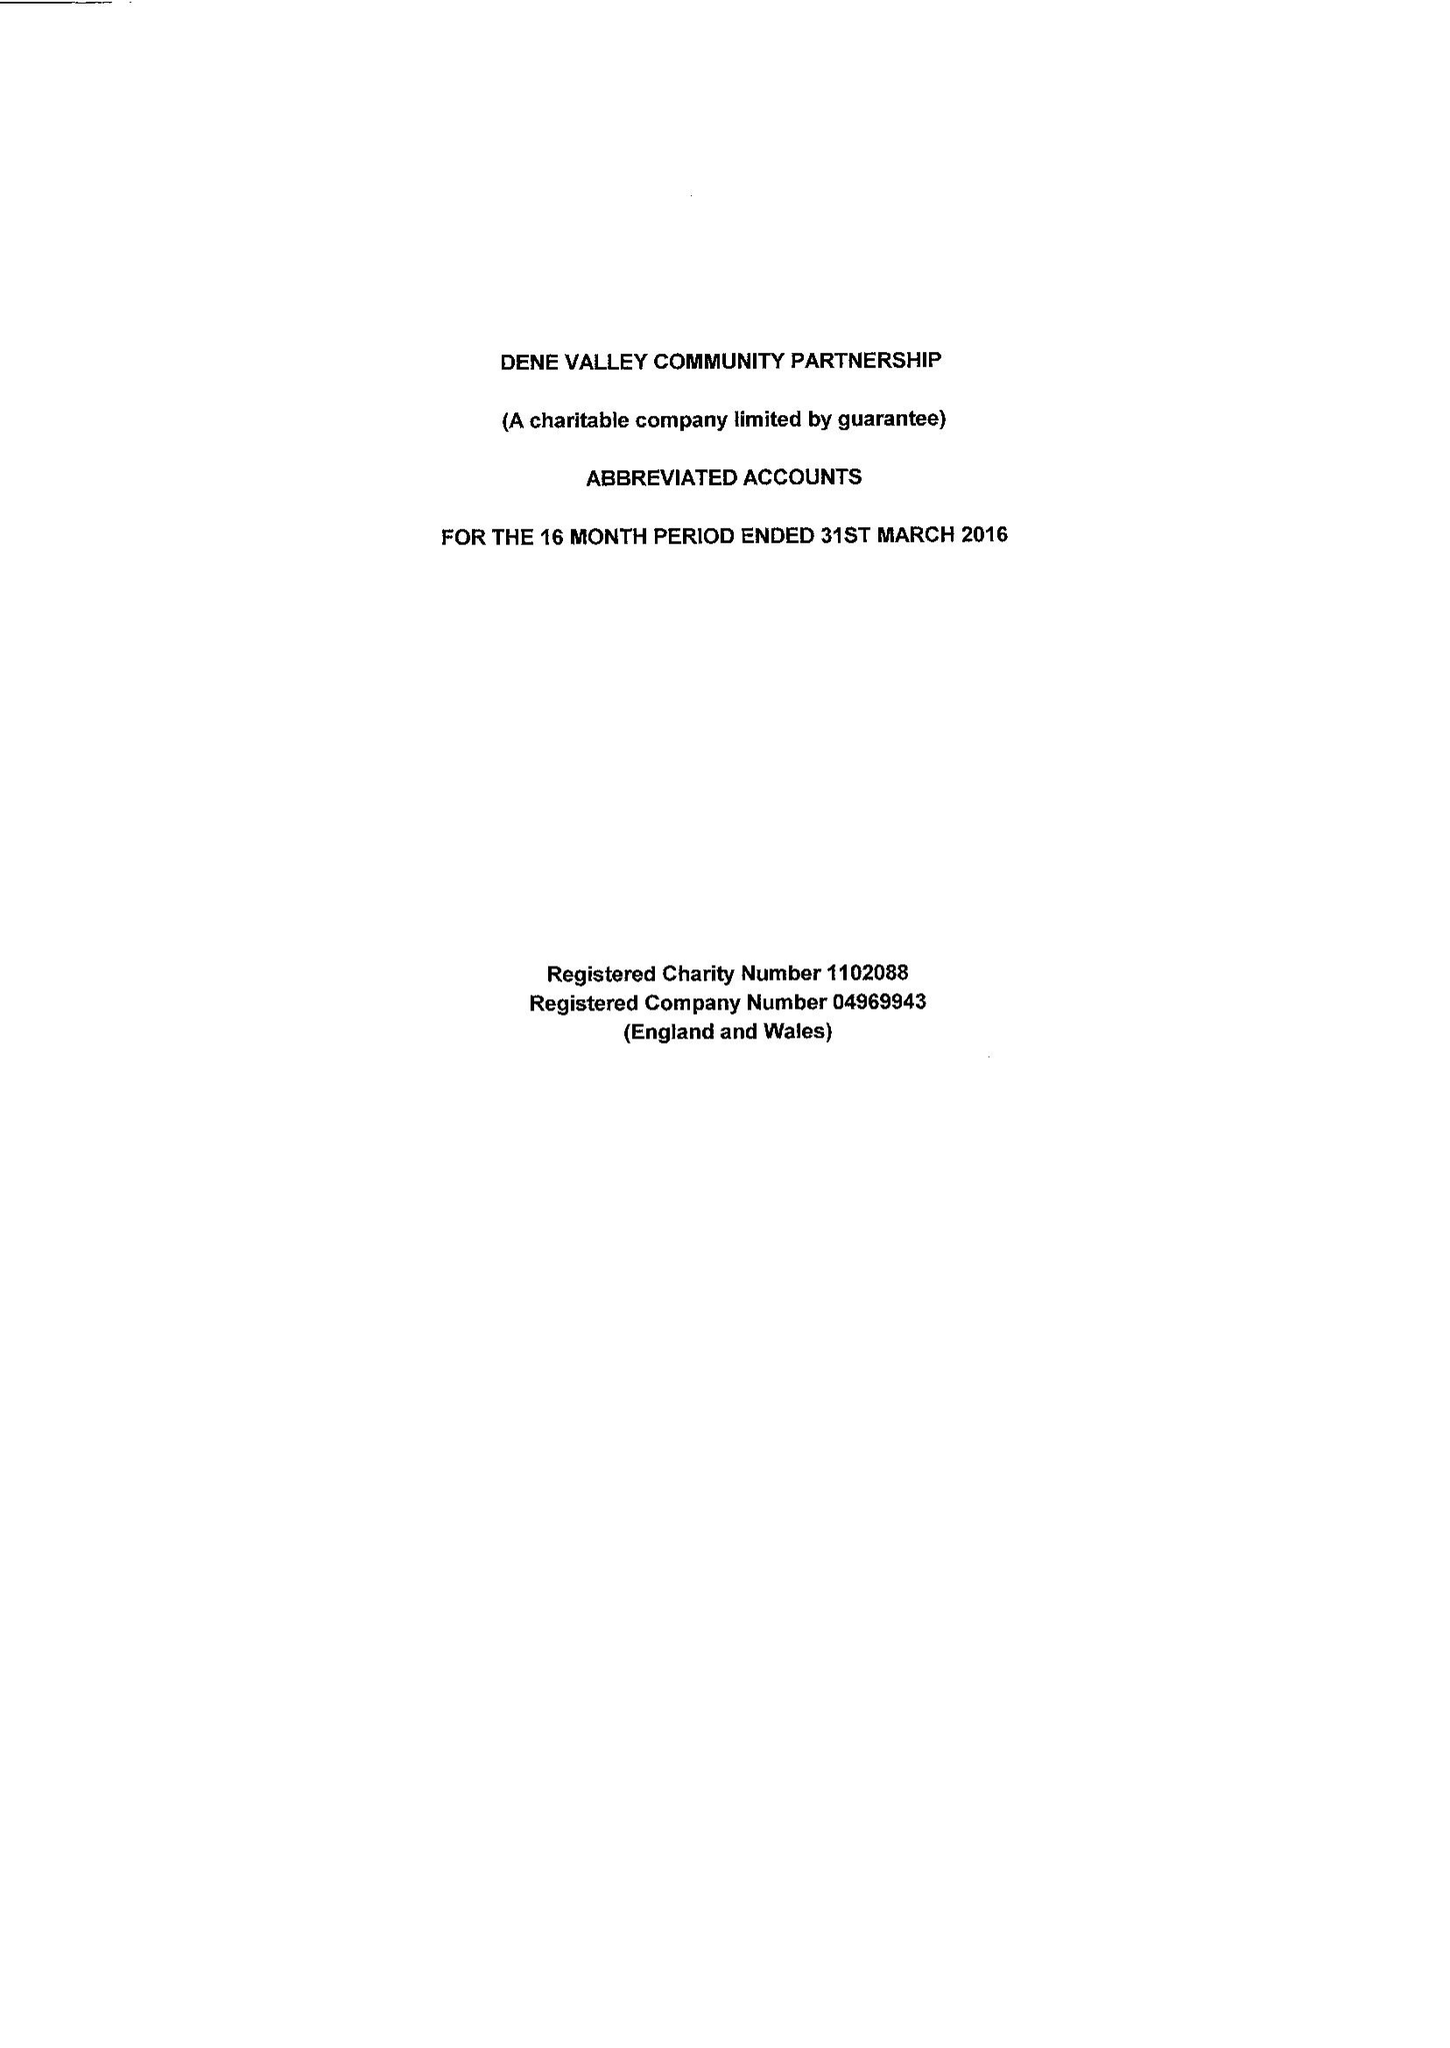What is the value for the income_annually_in_british_pounds?
Answer the question using a single word or phrase. 52000.00 